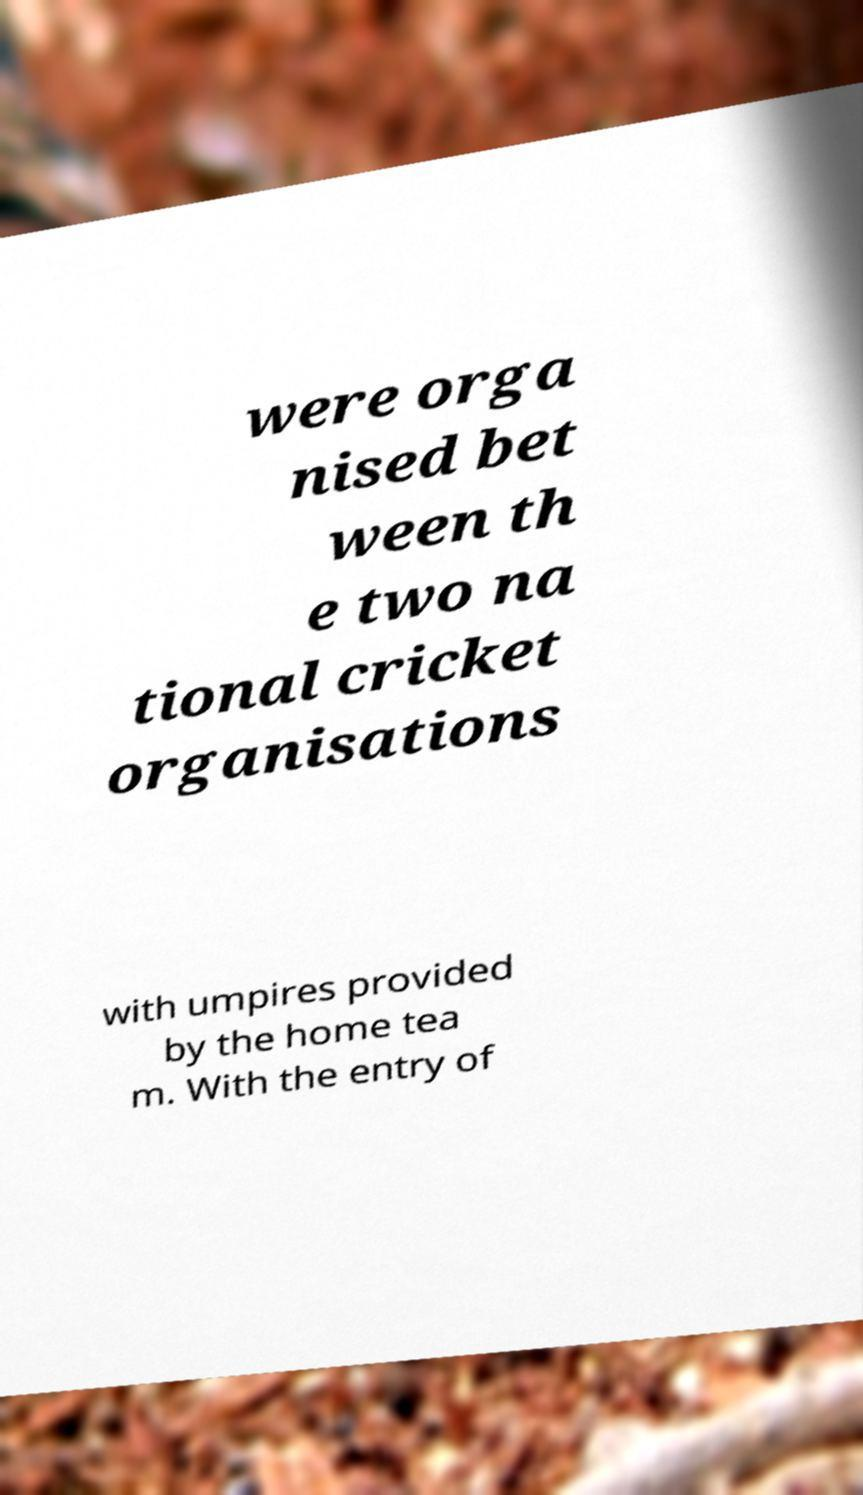Could you extract and type out the text from this image? were orga nised bet ween th e two na tional cricket organisations with umpires provided by the home tea m. With the entry of 